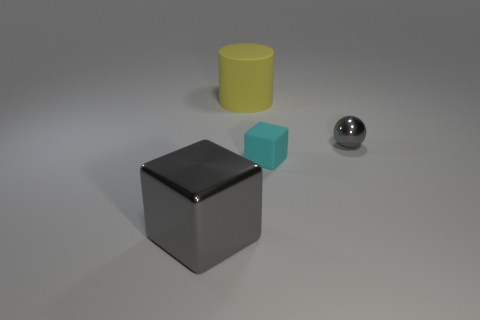What size is the block that is made of the same material as the big cylinder?
Keep it short and to the point. Small. Are there any large gray metal things that have the same shape as the cyan matte object?
Offer a terse response. Yes. What number of objects are gray metal objects to the right of the big metal block or red metallic things?
Make the answer very short. 1. The other thing that is the same color as the big metal thing is what size?
Offer a very short reply. Small. Do the cube to the right of the large yellow object and the big object left of the large cylinder have the same color?
Your response must be concise. No. How big is the yellow thing?
Provide a short and direct response. Large. How many small things are either green rubber blocks or cyan rubber objects?
Offer a very short reply. 1. There is a block that is the same size as the gray ball; what is its color?
Give a very brief answer. Cyan. What number of other objects are there of the same shape as the big yellow rubber thing?
Provide a short and direct response. 0. Is there a tiny gray ball that has the same material as the small cyan object?
Provide a succinct answer. No. 